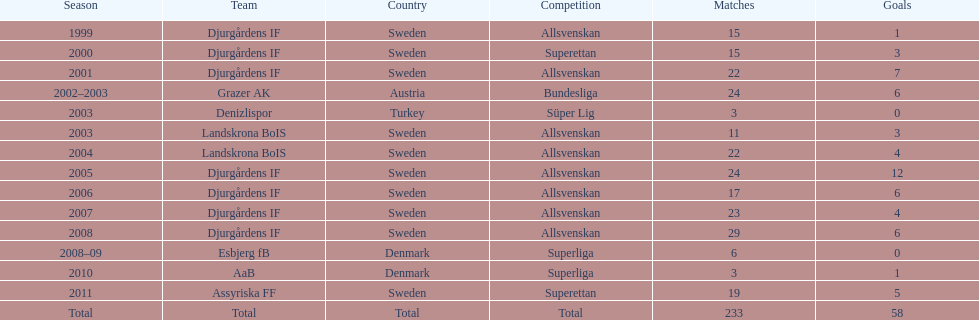What was the number of goals he scored in 2005? 12. 